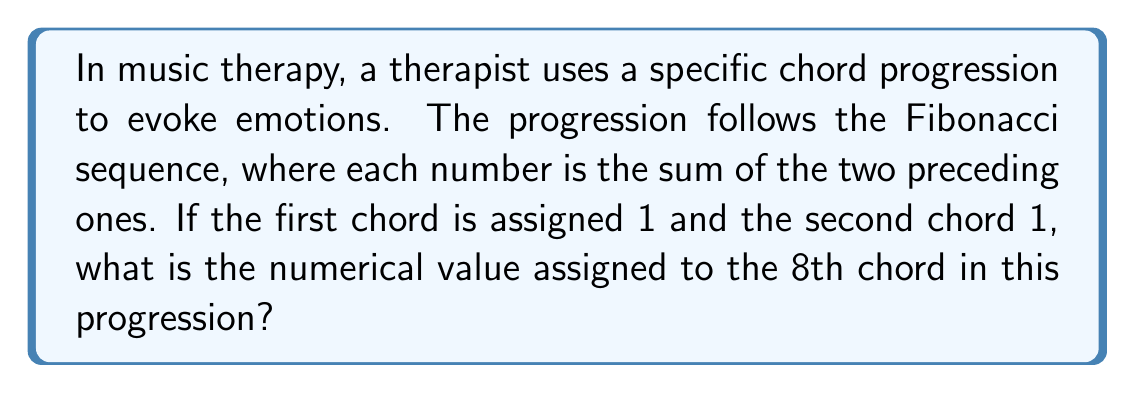Teach me how to tackle this problem. Let's approach this step-by-step:

1) The Fibonacci sequence starts with 1, 1 and each subsequent number is the sum of the two preceding ones.

2) Let's write out the sequence:
   $F_1 = 1$
   $F_2 = 1$
   $F_3 = F_1 + F_2 = 1 + 1 = 2$
   $F_4 = F_2 + F_3 = 1 + 2 = 3$
   $F_5 = F_3 + F_4 = 2 + 3 = 5$
   $F_6 = F_4 + F_5 = 3 + 5 = 8$
   $F_7 = F_5 + F_6 = 5 + 8 = 13$
   $F_8 = F_6 + F_7 = 8 + 13 = 21$

3) We can see that the 8th number in the sequence is 21.

4) In the context of music therapy, this could represent a chord with significant emotional impact due to its position in the sequence, potentially evoking a strong response from the patient.
Answer: 21 